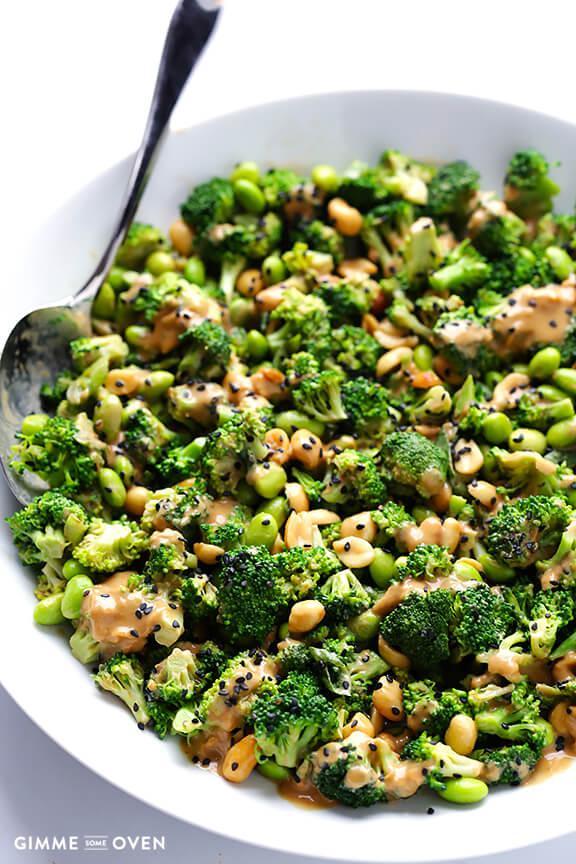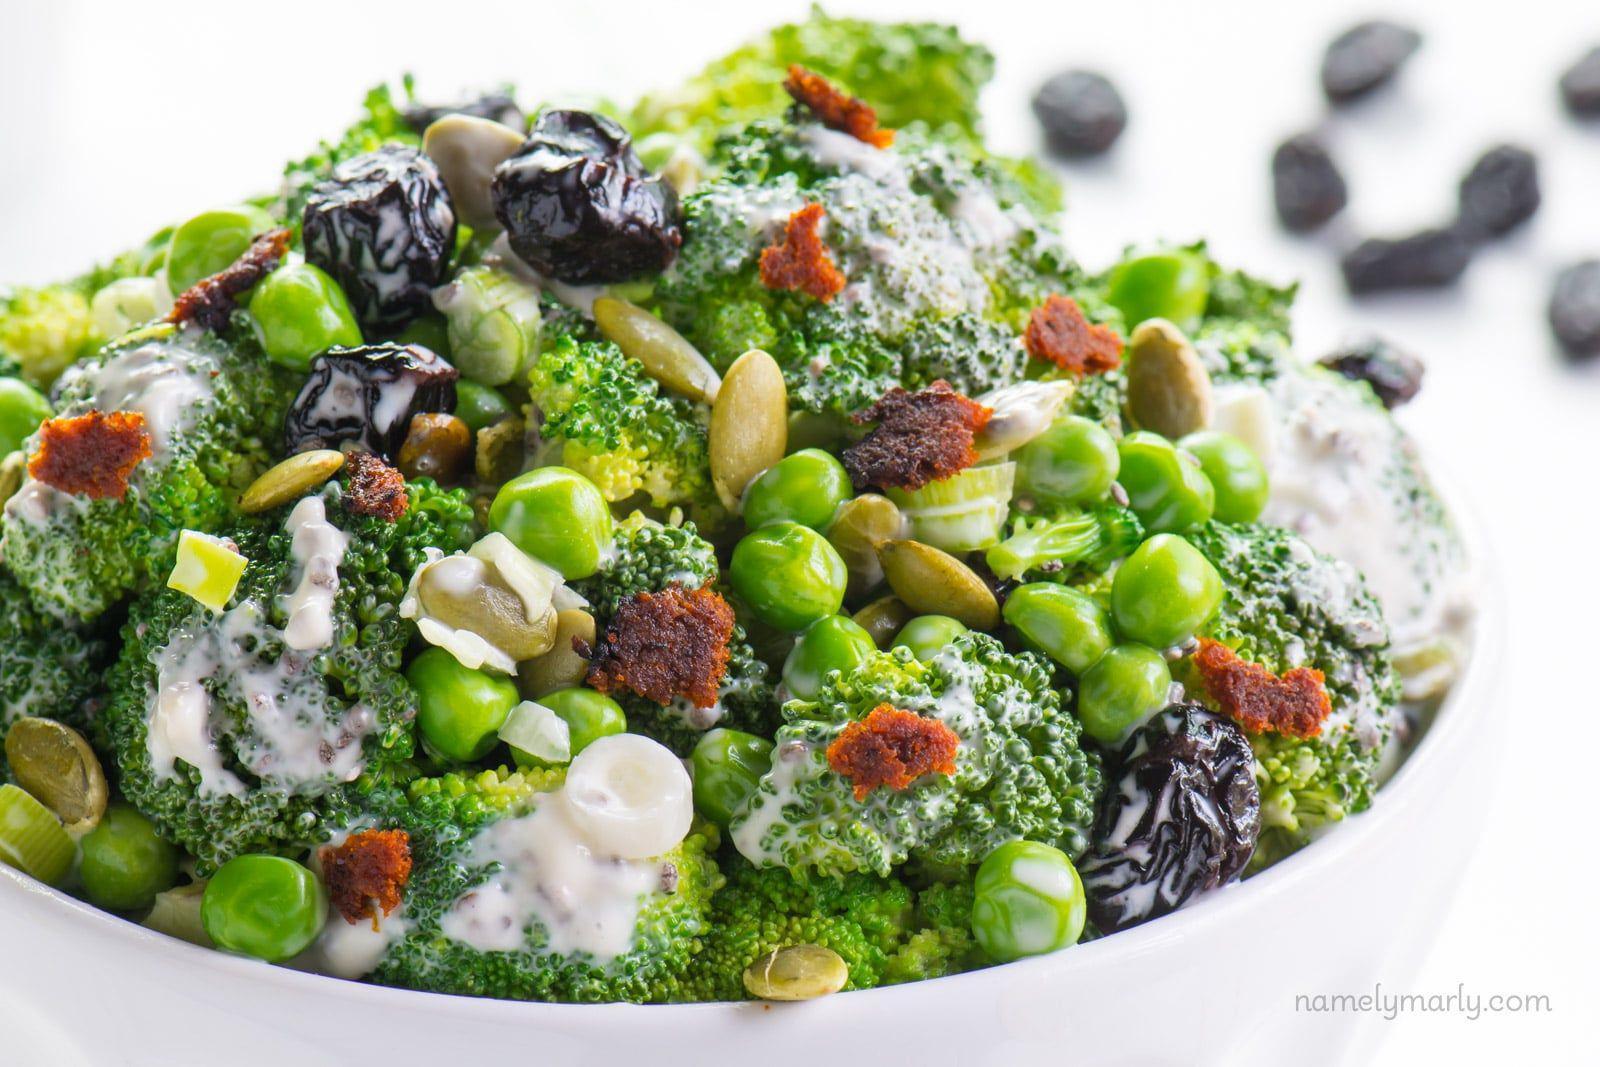The first image is the image on the left, the second image is the image on the right. For the images displayed, is the sentence "One image shows a piece of silverware on the edge of a round white handle-less dish containing broccoli florets." factually correct? Answer yes or no. Yes. The first image is the image on the left, the second image is the image on the right. Considering the images on both sides, is "The left and right image contains the same number of white bowls full of broccoli." valid? Answer yes or no. Yes. 